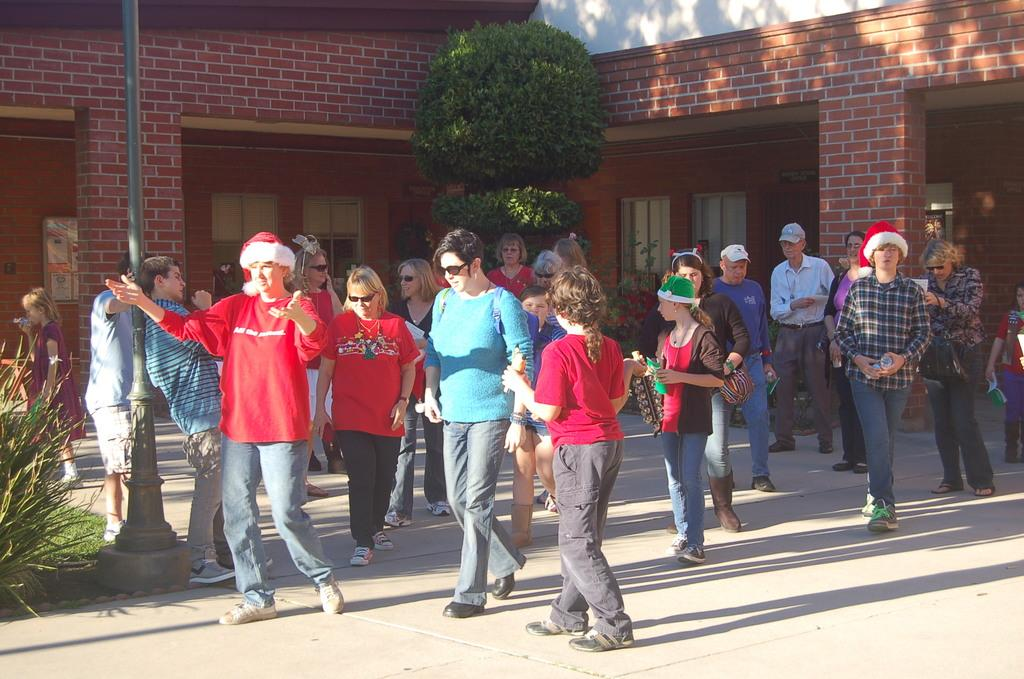How many people are present in the image? There is a group of people in the image. What else can be seen in the image besides the people? There are plants, windows, pillars, a pole, a board, and a building in the image. Can you describe the structure in the image? The image features a building with windows and pillars. What is the pole used for in the image? The purpose of the pole in the image cannot be determined from the provided facts. What type of sea creatures can be seen swimming in the image? There is no sea or sea creatures present in the image. Is there a party happening in the image? There is no indication of a party in the image. 